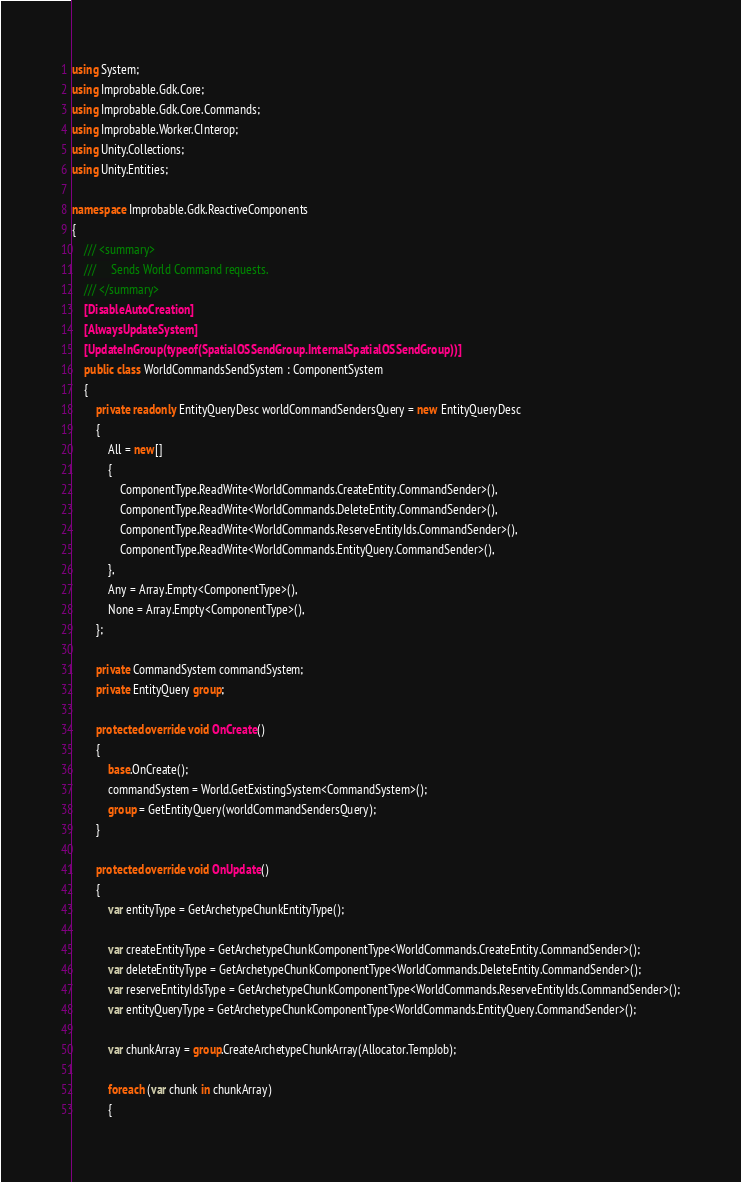<code> <loc_0><loc_0><loc_500><loc_500><_C#_>using System;
using Improbable.Gdk.Core;
using Improbable.Gdk.Core.Commands;
using Improbable.Worker.CInterop;
using Unity.Collections;
using Unity.Entities;

namespace Improbable.Gdk.ReactiveComponents
{
    /// <summary>
    ///     Sends World Command requests.
    /// </summary>
    [DisableAutoCreation]
    [AlwaysUpdateSystem]
    [UpdateInGroup(typeof(SpatialOSSendGroup.InternalSpatialOSSendGroup))]
    public class WorldCommandsSendSystem : ComponentSystem
    {
        private readonly EntityQueryDesc worldCommandSendersQuery = new EntityQueryDesc
        {
            All = new[]
            {
                ComponentType.ReadWrite<WorldCommands.CreateEntity.CommandSender>(),
                ComponentType.ReadWrite<WorldCommands.DeleteEntity.CommandSender>(),
                ComponentType.ReadWrite<WorldCommands.ReserveEntityIds.CommandSender>(),
                ComponentType.ReadWrite<WorldCommands.EntityQuery.CommandSender>(),
            },
            Any = Array.Empty<ComponentType>(),
            None = Array.Empty<ComponentType>(),
        };

        private CommandSystem commandSystem;
        private EntityQuery group;

        protected override void OnCreate()
        {
            base.OnCreate();
            commandSystem = World.GetExistingSystem<CommandSystem>();
            group = GetEntityQuery(worldCommandSendersQuery);
        }

        protected override void OnUpdate()
        {
            var entityType = GetArchetypeChunkEntityType();

            var createEntityType = GetArchetypeChunkComponentType<WorldCommands.CreateEntity.CommandSender>();
            var deleteEntityType = GetArchetypeChunkComponentType<WorldCommands.DeleteEntity.CommandSender>();
            var reserveEntityIdsType = GetArchetypeChunkComponentType<WorldCommands.ReserveEntityIds.CommandSender>();
            var entityQueryType = GetArchetypeChunkComponentType<WorldCommands.EntityQuery.CommandSender>();

            var chunkArray = group.CreateArchetypeChunkArray(Allocator.TempJob);

            foreach (var chunk in chunkArray)
            {</code> 